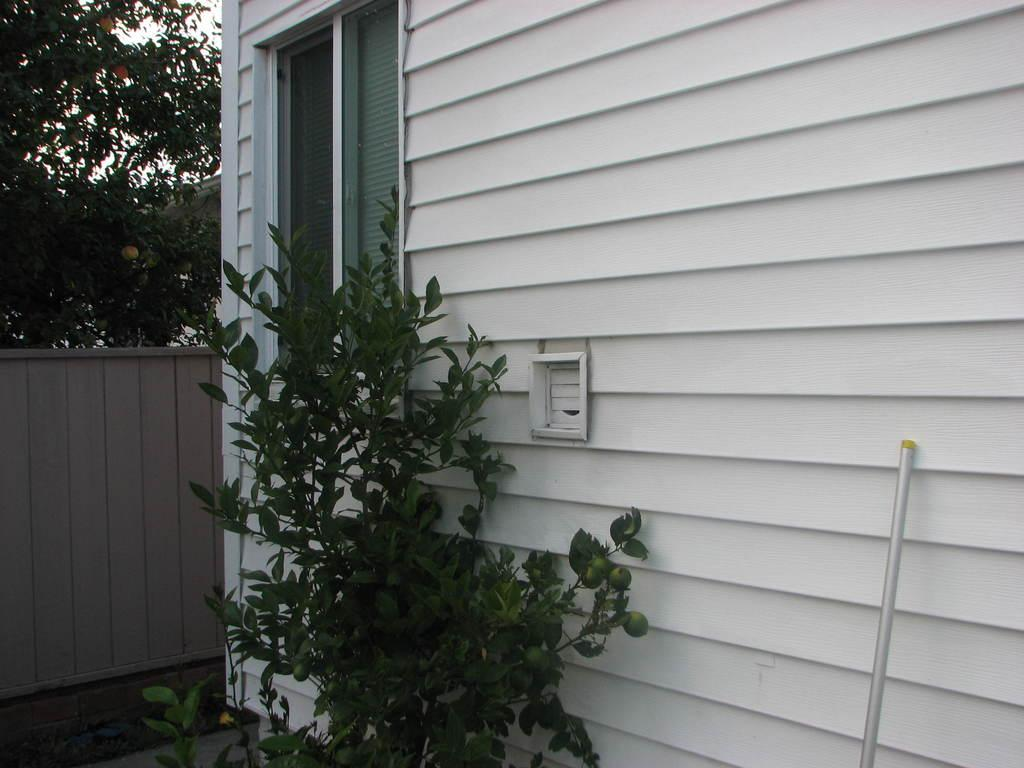What type of structure is visible in the image? There is a house in the image. What type of vegetation can be seen in the image? There is a plant and a tree in the image. Can you describe the object on the right side of the image? Unfortunately, the facts provided do not give any details about the object on the right side of the image. How many eggs are on the tree in the image? There are no eggs present in the image; it features a house, a plant, and a tree. What type of linen is draped over the house in the image? There is no linen present in the image; it only shows a house, a plant, a tree, and an object on the right side. 